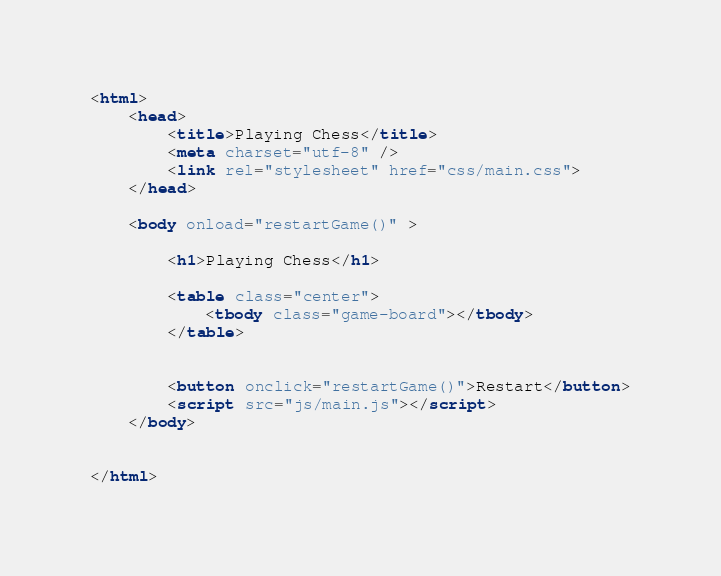<code> <loc_0><loc_0><loc_500><loc_500><_HTML_><html>
    <head>
        <title>Playing Chess</title>
        <meta charset="utf-8" />
        <link rel="stylesheet" href="css/main.css">
    </head>
    
    <body onload="restartGame()" >

        <h1>Playing Chess</h1>
        
        <table class="center">
            <tbody class="game-board"></tbody>
        </table>


        <button onclick="restartGame()">Restart</button>
        <script src="js/main.js"></script>    
    </body>
    
    
</html>    </code> 